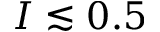Convert formula to latex. <formula><loc_0><loc_0><loc_500><loc_500>I \lesssim 0 . 5</formula> 